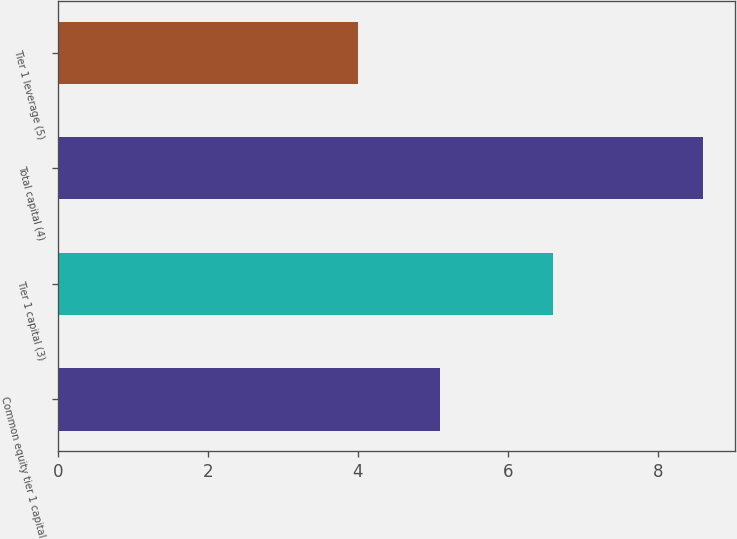Convert chart to OTSL. <chart><loc_0><loc_0><loc_500><loc_500><bar_chart><fcel>Common equity tier 1 capital<fcel>Tier 1 capital (3)<fcel>Total capital (4)<fcel>Tier 1 leverage (5)<nl><fcel>5.1<fcel>6.6<fcel>8.6<fcel>4<nl></chart> 